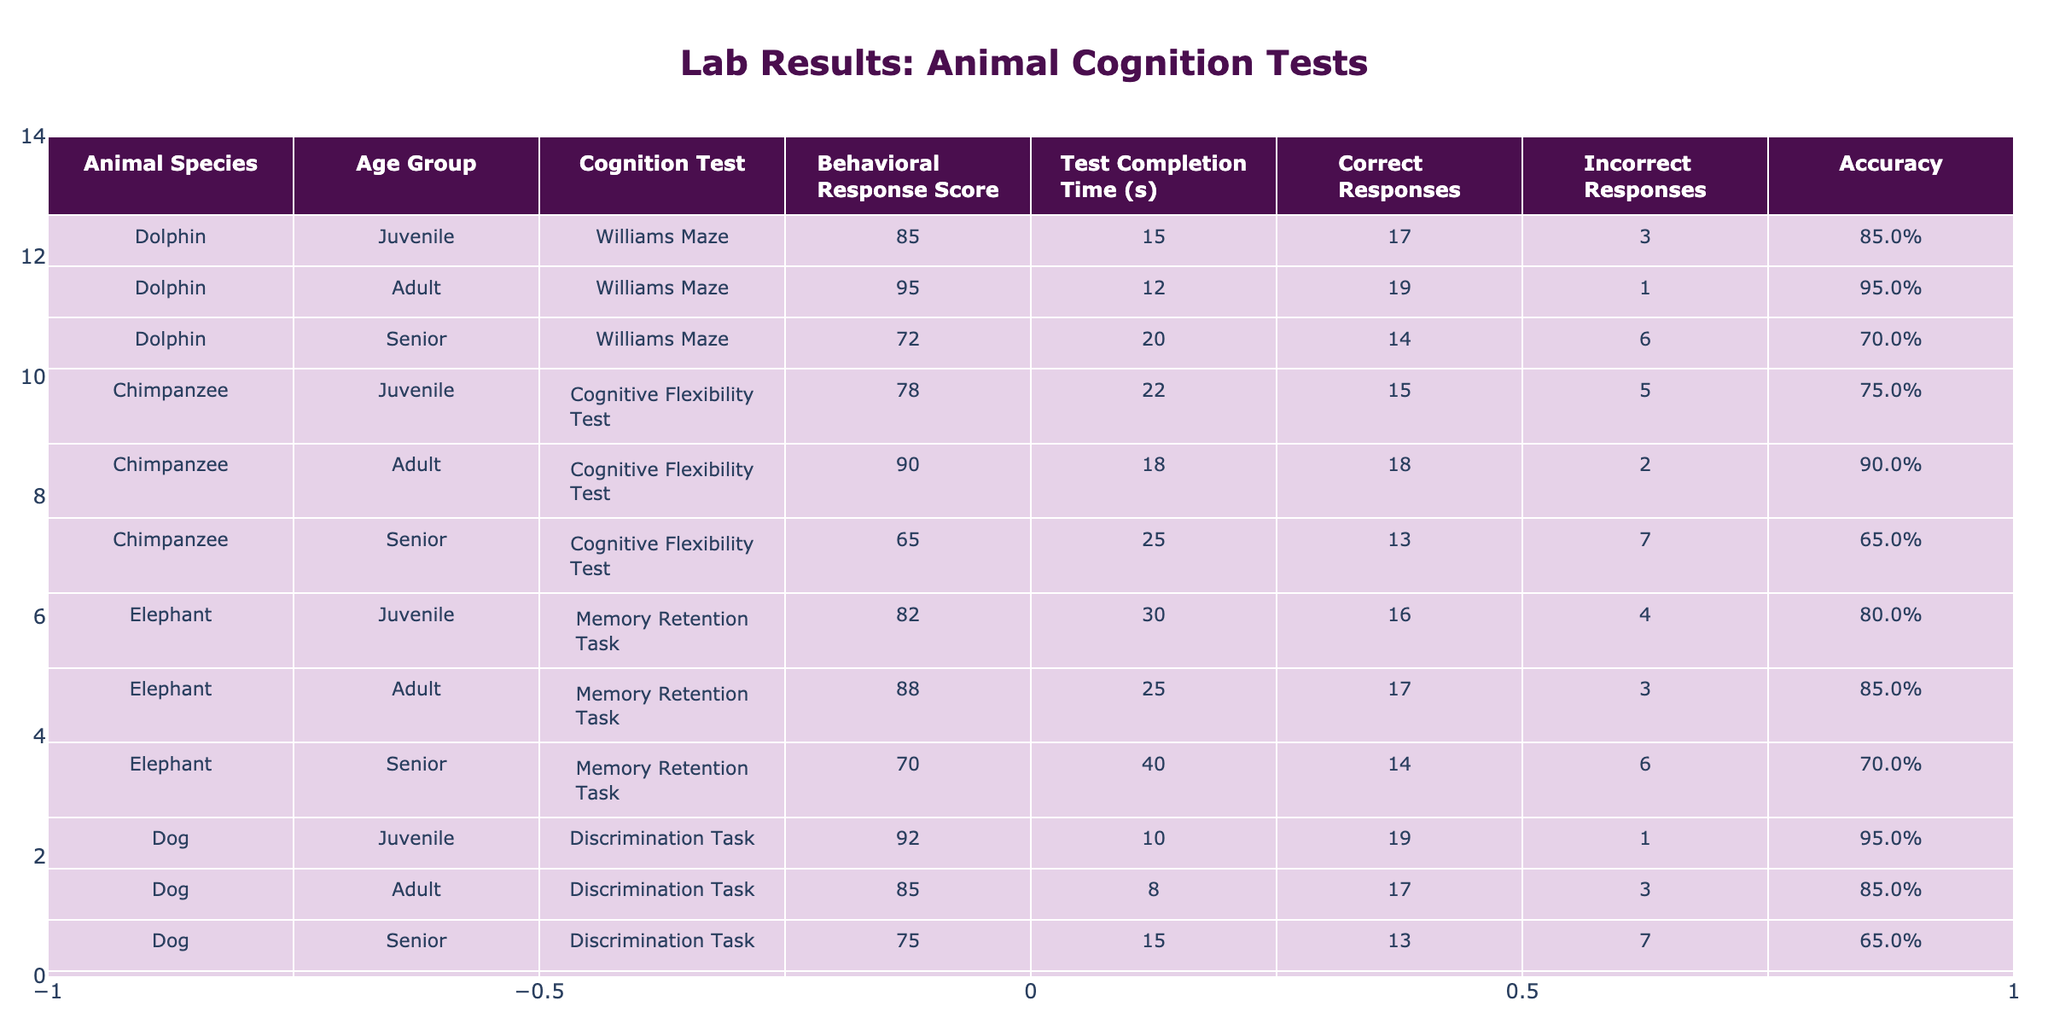What is the Behavioral Response Score of the Adult Dolphin in the Williams Maze? The table shows the row for the Adult Dolphin under the Williams Maze. The Behavioral Response Score in that row is 95.
Answer: 95 How much time did the Senior Chimpanzee take to complete the Cognitive Flexibility Test? Referring to the row for the Senior Chimpanzee in the table, the Test Completion Time is noted as 25 seconds.
Answer: 25 seconds Which age group of Elephants had the highest Behavioral Response Score? The table lists the scores for Elephants across three age groups: Juvenile (82), Adult (88), and Senior (70). The highest score is 88 for the Adult group.
Answer: Adult What is the total number of Correct Responses given by the Junior Elephant in the Memory Retention Task? Looking at the table, the Correct Responses for the Juvenile Elephant in the Memory Retention Task is recorded as 16.
Answer: 16 Did any animal species have a higher Accuracy in their tests than the Adult Dog? The Adult Dog has an Accuracy of 85.3%. By reviewing the accuracy of all species: Dolphin (Adult: 95.0%), Chimpanzee (Adult: 90.0%), Elephant (Adult: 88.0%), and Parrot (Adult: 90.0%) indicate they all had a higher accuracy than the Adult Dog.
Answer: Yes What is the average Behavioral Response Score of all Senior animals? The scores for Senior animals are: Dolphin (72), Chimpanzee (65), Elephant (70), Dog (75), and Parrot (68). Summing these gives 72 + 65 + 70 + 75 + 68 = 350. There are 5 data points, so the average is 350 / 5 = 70.
Answer: 70 Which animal species had the highest number of Correct Responses in their tests? By checking all the rows, the Dog (Juvenile) scored the highest with 19 Correct Responses. Thus, the Giant Dog has the highest score.
Answer: Dog (Juvenile) What is the difference in Test Completion Time between the Senior Dolphin and Senior Elephant? The Senior Dolphin took 40 seconds while the Senior Elephant completed in 20 seconds. The difference is 40 - 20 = 20 seconds.
Answer: 20 seconds What is the percentage of Correct Responses for the Adult Chimpanzee? The Adult Chimpanzee had 18 Correct Responses and 2 Incorrect Responses, totaling 18 + 2 = 20 responses. The percentage is (18 / 20) * 100 = 90%.
Answer: 90% 